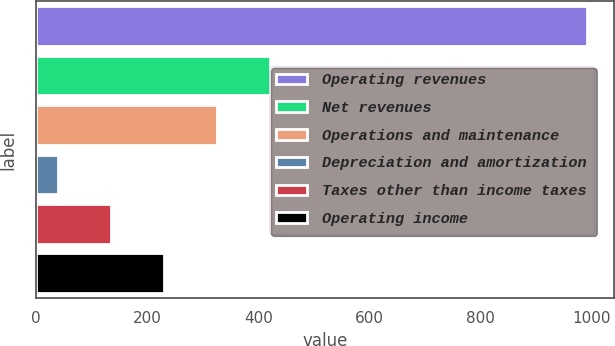<chart> <loc_0><loc_0><loc_500><loc_500><bar_chart><fcel>Operating revenues<fcel>Net revenues<fcel>Operations and maintenance<fcel>Depreciation and amortization<fcel>Taxes other than income taxes<fcel>Operating income<nl><fcel>991<fcel>420.4<fcel>325.3<fcel>40<fcel>135.1<fcel>230.2<nl></chart> 